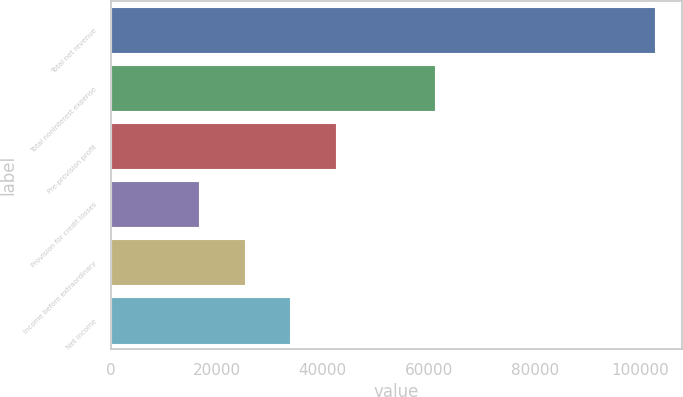Convert chart to OTSL. <chart><loc_0><loc_0><loc_500><loc_500><bar_chart><fcel>Total net revenue<fcel>Total noninterest expense<fcel>Pre-provision profit<fcel>Provision for credit losses<fcel>Income before extraordinary<fcel>Net income<nl><fcel>102694<fcel>61196<fcel>42455.5<fcel>16639<fcel>25244.5<fcel>33850<nl></chart> 